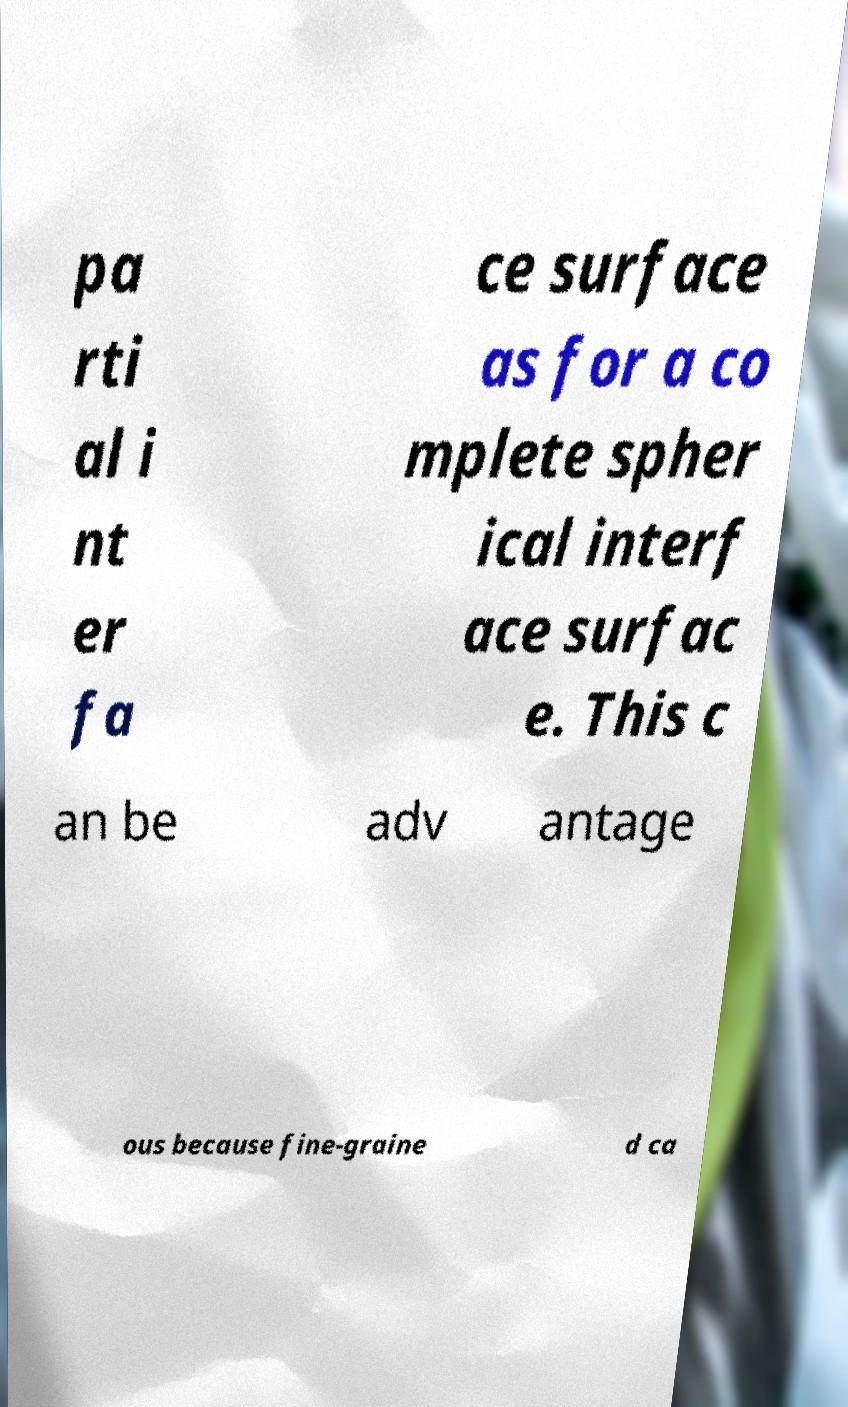For documentation purposes, I need the text within this image transcribed. Could you provide that? pa rti al i nt er fa ce surface as for a co mplete spher ical interf ace surfac e. This c an be adv antage ous because fine-graine d ca 